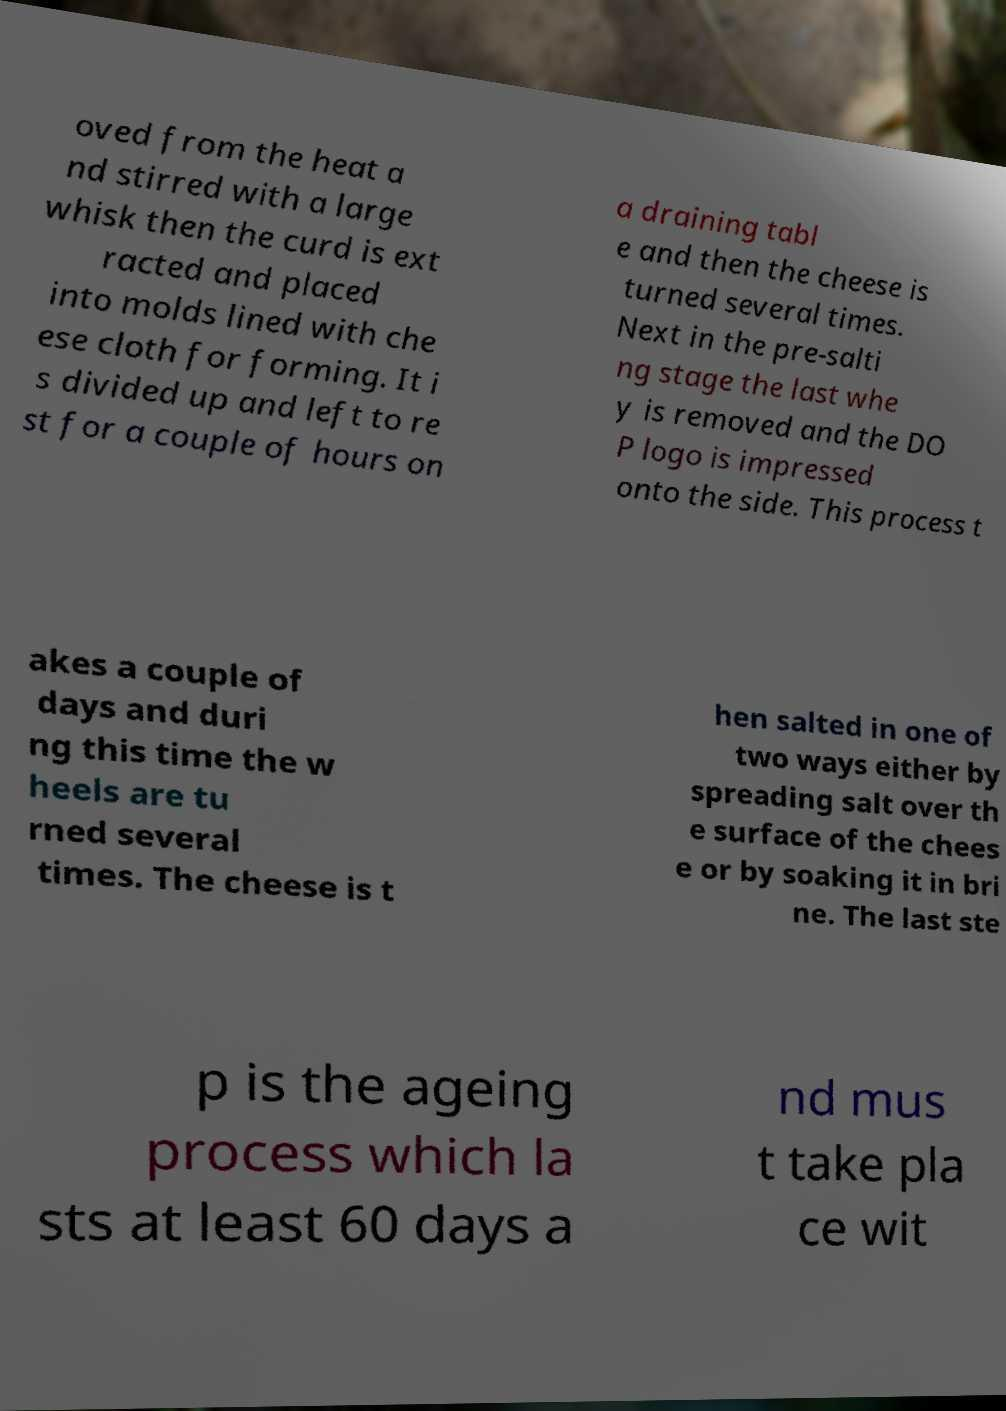Can you accurately transcribe the text from the provided image for me? oved from the heat a nd stirred with a large whisk then the curd is ext racted and placed into molds lined with che ese cloth for forming. It i s divided up and left to re st for a couple of hours on a draining tabl e and then the cheese is turned several times. Next in the pre-salti ng stage the last whe y is removed and the DO P logo is impressed onto the side. This process t akes a couple of days and duri ng this time the w heels are tu rned several times. The cheese is t hen salted in one of two ways either by spreading salt over th e surface of the chees e or by soaking it in bri ne. The last ste p is the ageing process which la sts at least 60 days a nd mus t take pla ce wit 